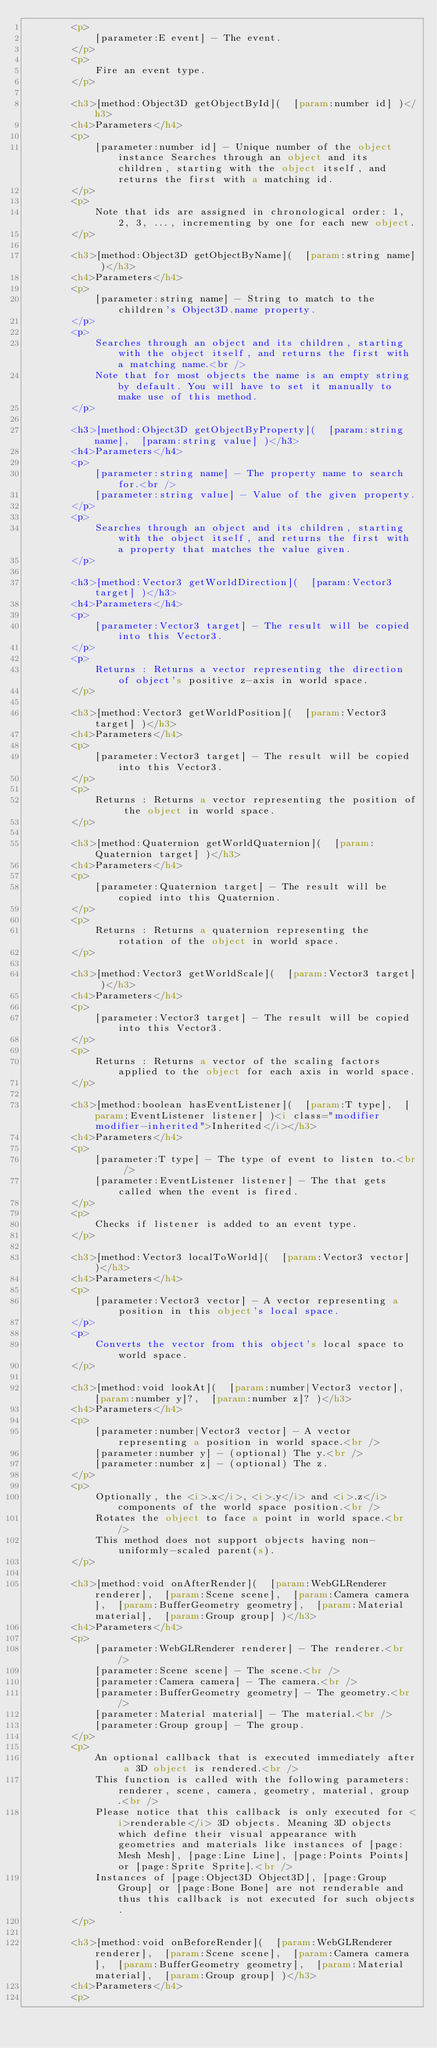<code> <loc_0><loc_0><loc_500><loc_500><_HTML_>		<p>
			[parameter:E event] - The event.
		</p>
		<p>
			Fire an event type.
		</p>

		<h3>[method:Object3D getObjectById](  [param:number id] )</h3>
		<h4>Parameters</h4>
		<p>
			[parameter:number id] - Unique number of the object instance Searches through an object and its children, starting with the object itself, and returns the first with a matching id.
		</p>
		<p>
			Note that ids are assigned in chronological order: 1, 2, 3, ..., incrementing by one for each new object.
		</p>

		<h3>[method:Object3D getObjectByName](  [param:string name] )</h3>
		<h4>Parameters</h4>
		<p>
			[parameter:string name] - String to match to the children's Object3D.name property.
		</p>
		<p>
			Searches through an object and its children, starting with the object itself, and returns the first with a matching name.<br />
			Note that for most objects the name is an empty string by default. You will have to set it manually to make use of this method.
		</p>

		<h3>[method:Object3D getObjectByProperty](  [param:string name],  [param:string value] )</h3>
		<h4>Parameters</h4>
		<p>
			[parameter:string name] - The property name to search for.<br />
			[parameter:string value] - Value of the given property.
		</p>
		<p>
			Searches through an object and its children, starting with the object itself, and returns the first with a property that matches the value given.
		</p>

		<h3>[method:Vector3 getWorldDirection](  [param:Vector3 target] )</h3>
		<h4>Parameters</h4>
		<p>
			[parameter:Vector3 target] - The result will be copied into this Vector3.
		</p>
		<p>
			Returns : Returns a vector representing the direction of object's positive z-axis in world space.
		</p>

		<h3>[method:Vector3 getWorldPosition](  [param:Vector3 target] )</h3>
		<h4>Parameters</h4>
		<p>
			[parameter:Vector3 target] - The result will be copied into this Vector3.
		</p>
		<p>
			Returns : Returns a vector representing the position of the object in world space.
		</p>

		<h3>[method:Quaternion getWorldQuaternion](  [param:Quaternion target] )</h3>
		<h4>Parameters</h4>
		<p>
			[parameter:Quaternion target] - The result will be copied into this Quaternion.
		</p>
		<p>
			Returns : Returns a quaternion representing the rotation of the object in world space.
		</p>

		<h3>[method:Vector3 getWorldScale](  [param:Vector3 target] )</h3>
		<h4>Parameters</h4>
		<p>
			[parameter:Vector3 target] - The result will be copied into this Vector3.
		</p>
		<p>
			Returns : Returns a vector of the scaling factors applied to the object for each axis in world space.
		</p>

		<h3>[method:boolean hasEventListener](  [param:T type],  [param:EventListener listener] )<i class="modifier modifier-inherited">Inherited</i></h3>
		<h4>Parameters</h4>
		<p>
			[parameter:T type] - The type of event to listen to.<br />
			[parameter:EventListener listener] - The that gets called when the event is fired.
		</p>
		<p>
			Checks if listener is added to an event type.
		</p>

		<h3>[method:Vector3 localToWorld](  [param:Vector3 vector] )</h3>
		<h4>Parameters</h4>
		<p>
			[parameter:Vector3 vector] - A vector representing a position in this object's local space.
		</p>
		<p>
			Converts the vector from this object's local space to world space.
		</p>

		<h3>[method:void lookAt](  [param:number|Vector3 vector],  [param:number y]?,  [param:number z]? )</h3>
		<h4>Parameters</h4>
		<p>
			[parameter:number|Vector3 vector] - A vector representing a position in world space.<br />
			[parameter:number y] - (optional) The y.<br />
			[parameter:number z] - (optional) The z.
		</p>
		<p>
			Optionally, the <i>.x</i>, <i>.y</i> and <i>.z</i> components of the world space position.<br />
			Rotates the object to face a point in world space.<br />
			This method does not support objects having non-uniformly-scaled parent(s).
		</p>

		<h3>[method:void onAfterRender](  [param:WebGLRenderer renderer],  [param:Scene scene],  [param:Camera camera],  [param:BufferGeometry geometry],  [param:Material material],  [param:Group group] )</h3>
		<h4>Parameters</h4>
		<p>
			[parameter:WebGLRenderer renderer] - The renderer.<br />
			[parameter:Scene scene] - The scene.<br />
			[parameter:Camera camera] - The camera.<br />
			[parameter:BufferGeometry geometry] - The geometry.<br />
			[parameter:Material material] - The material.<br />
			[parameter:Group group] - The group.
		</p>
		<p>
			An optional callback that is executed immediately after a 3D object is rendered.<br />
			This function is called with the following parameters: renderer, scene, camera, geometry, material, group.<br />
			Please notice that this callback is only executed for <i>renderable</i> 3D objects. Meaning 3D objects which define their visual appearance with geometries and materials like instances of [page:Mesh Mesh], [page:Line Line], [page:Points Points] or [page:Sprite Sprite].<br />
			Instances of [page:Object3D Object3D], [page:Group Group] or [page:Bone Bone] are not renderable and thus this callback is not executed for such objects.
		</p>

		<h3>[method:void onBeforeRender](  [param:WebGLRenderer renderer],  [param:Scene scene],  [param:Camera camera],  [param:BufferGeometry geometry],  [param:Material material],  [param:Group group] )</h3>
		<h4>Parameters</h4>
		<p></code> 